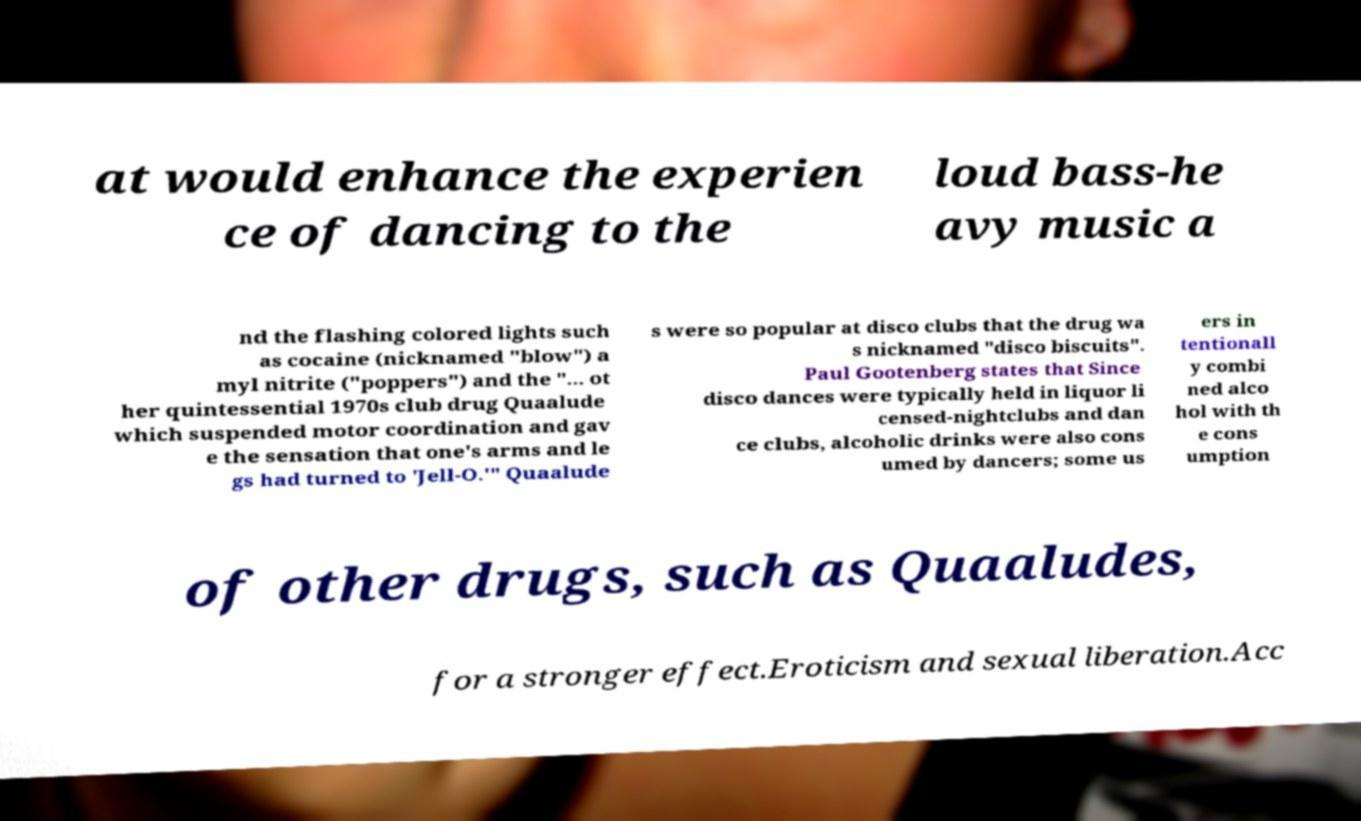Could you extract and type out the text from this image? at would enhance the experien ce of dancing to the loud bass-he avy music a nd the flashing colored lights such as cocaine (nicknamed "blow") a myl nitrite ("poppers") and the "... ot her quintessential 1970s club drug Quaalude which suspended motor coordination and gav e the sensation that one's arms and le gs had turned to 'Jell-O.'" Quaalude s were so popular at disco clubs that the drug wa s nicknamed "disco biscuits". Paul Gootenberg states that Since disco dances were typically held in liquor li censed-nightclubs and dan ce clubs, alcoholic drinks were also cons umed by dancers; some us ers in tentionall y combi ned alco hol with th e cons umption of other drugs, such as Quaaludes, for a stronger effect.Eroticism and sexual liberation.Acc 